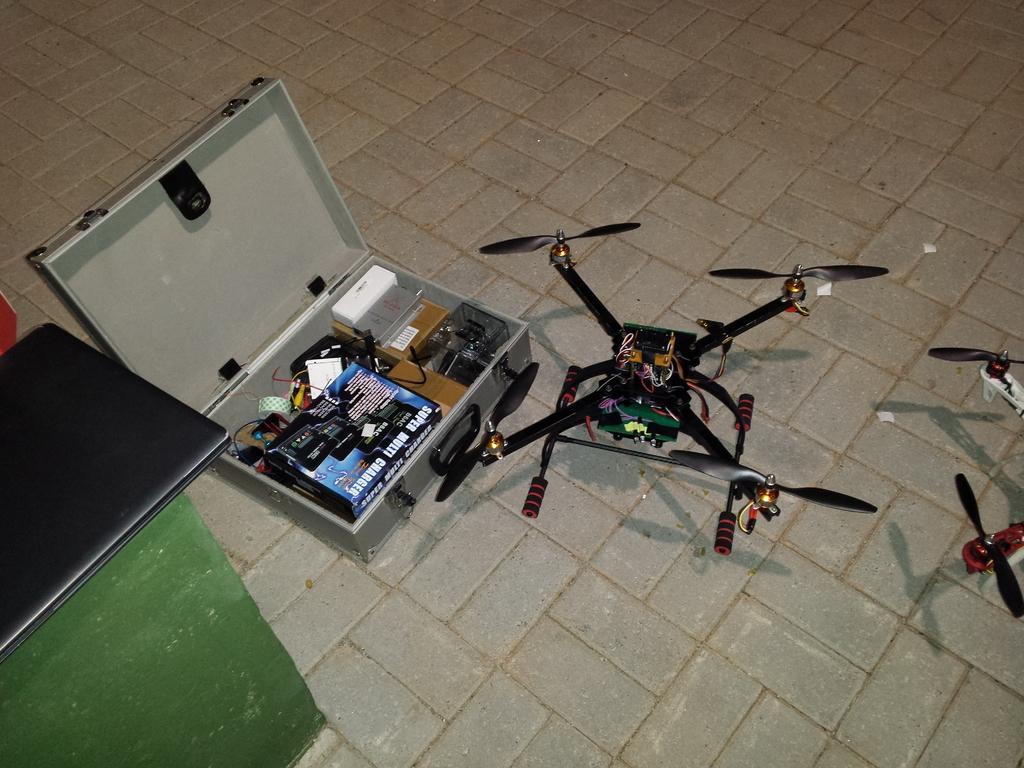Could you give a brief overview of what you see in this image? There is a briefcase in which there are few items. There is a drone on the floor. 